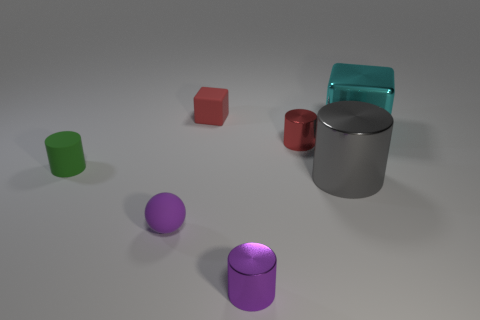Is there any other thing of the same color as the rubber sphere?
Offer a very short reply. Yes. How many gray blocks are the same size as the purple ball?
Your answer should be compact. 0. There is a small object that is both right of the tiny ball and in front of the green object; what material is it?
Provide a succinct answer. Metal. There is a tiny rubber cylinder; what number of large things are on the left side of it?
Your response must be concise. 0. There is a small green matte object; is its shape the same as the large thing behind the red cylinder?
Ensure brevity in your answer.  No. Is there a small brown rubber object of the same shape as the purple rubber thing?
Offer a terse response. No. What shape is the small metallic thing in front of the small thing on the right side of the tiny purple metal cylinder?
Make the answer very short. Cylinder. The cyan thing that is right of the small red matte object has what shape?
Ensure brevity in your answer.  Cube. Do the small cylinder that is behind the tiny green matte cylinder and the block that is behind the cyan object have the same color?
Give a very brief answer. Yes. What number of large objects are both on the left side of the big cyan block and behind the green cylinder?
Make the answer very short. 0. 